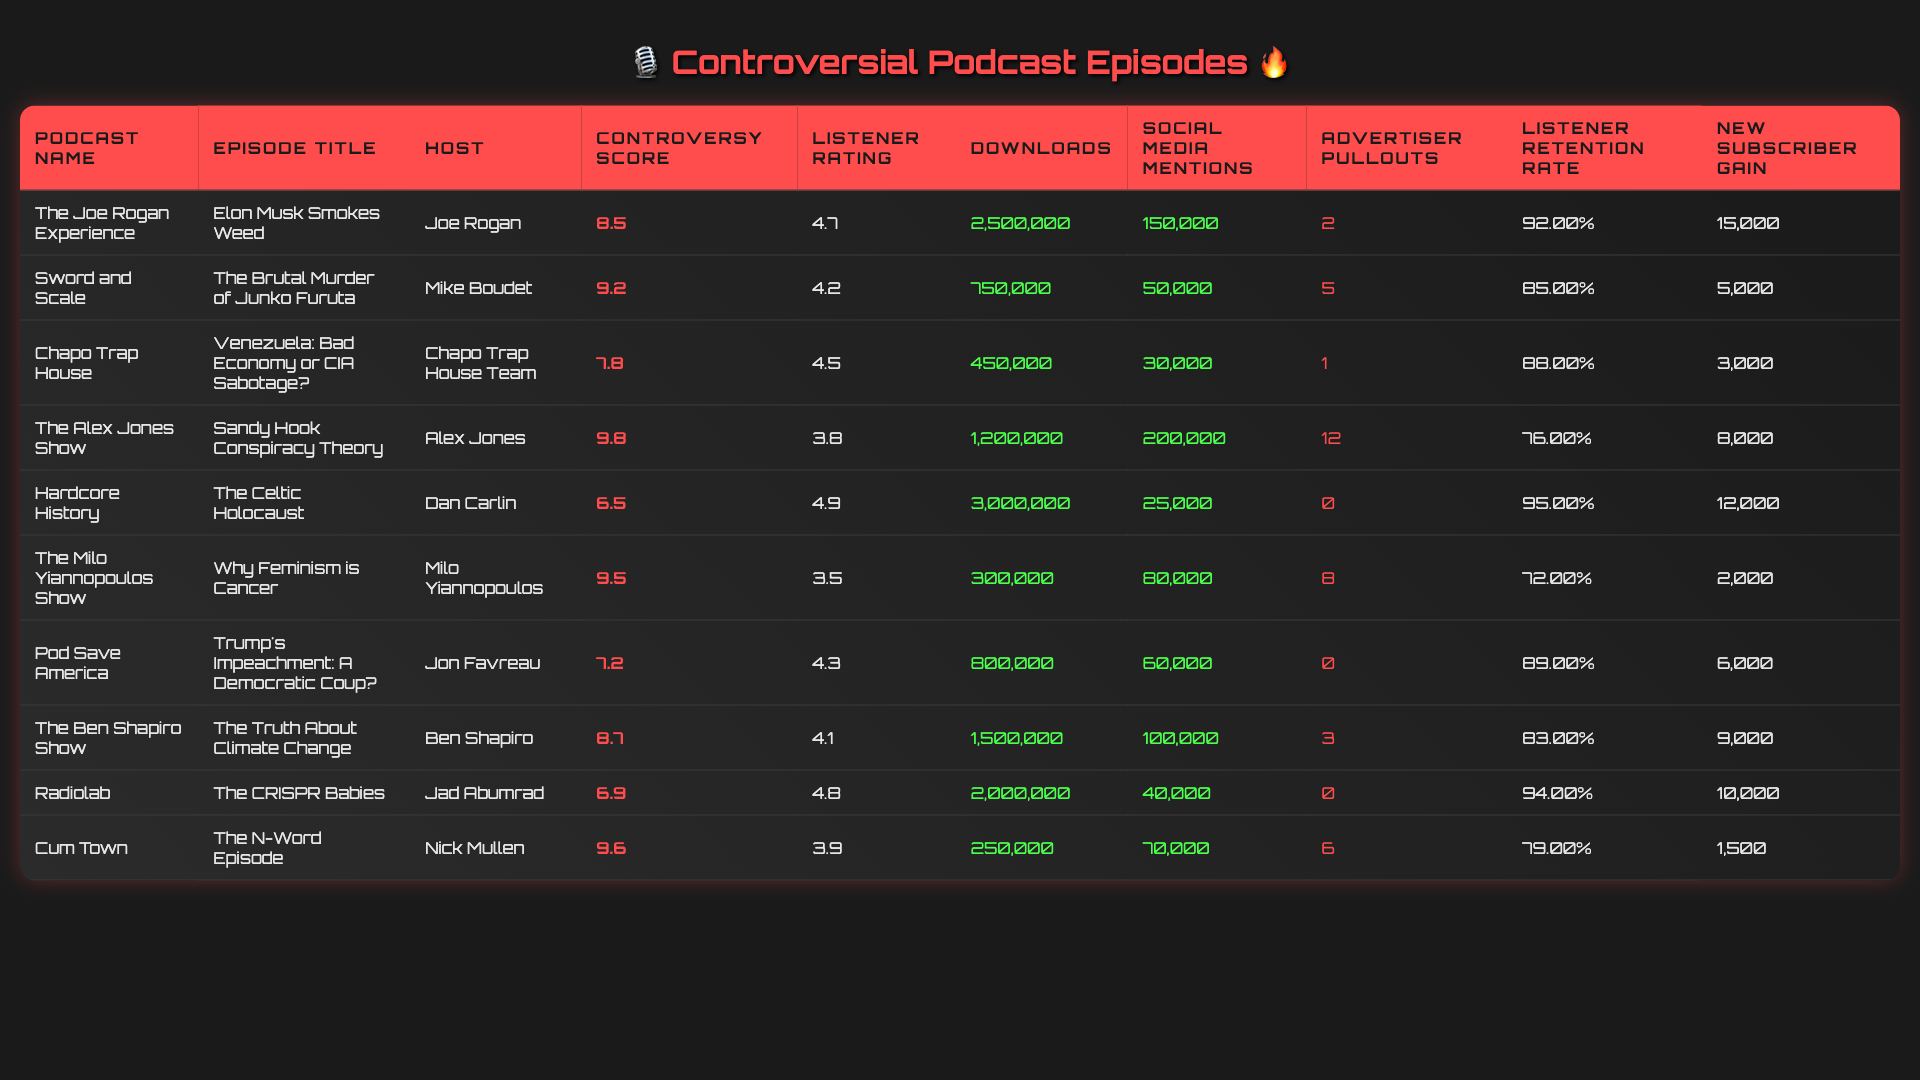What is the podcast with the highest controversy score? By scanning the controversy scores listed in the table, "The Alex Jones Show" has the highest score of 9.8.
Answer: The Alex Jones Show Which episode had the lowest listener rating? Looking at the listener ratings, "The Milo Yiannopoulos Show" has the lowest rating of 3.5.
Answer: The Milo Yiannopoulos Show How many downloads did "Cum Town" have? The table shows that "Cum Town" had 250,000 downloads.
Answer: 250,000 What is the average listener retention rate for the podcasts listed? The listener retention rates are 0.92, 0.85, 0.88, 0.76, 0.95, 0.72, 0.89, 0.83, 0.94, and 0.79. If we sum these values, we get 8.88, and dividing by 10 gives an average of 0.888 or 88.8%.
Answer: 88.8% Did any podcast have no advertiser pullouts? By reviewing the advertiser pullouts, "Hardcore History," "Pod Save America," and "The CRISPR Babies" had zero advertiser pullouts. Hence, the answer is yes.
Answer: Yes Which podcast had the highest downloads among those with a controversy score over 9? The podcasts with a score over 9 are "The Alex Jones Show," "Sword and Scale," and "The Milo Yiannopoulos Show." Among these, "The Alex Jones Show" has 1,200,000 downloads, which is the highest.
Answer: The Alex Jones Show What is the total number of social media mentions for "Elon Musk Smokes Weed" and "The N-Word Episode"? For "Elon Musk Smokes Weed," there are 150,000 mentions; for "The N-Word Episode," there are 70,000. Therefore, the total is 150,000 + 70,000 = 220,000 mentions.
Answer: 220,000 Which podcast had the highest new subscriber gain? According to the table, "The Joe Rogan Experience" had the highest new subscriber gain of 15,000.
Answer: The Joe Rogan Experience Is there a relationship between controversy score and listener retention rate? A higher controversy score does not necessarily correlate with a higher listener retention rate. For example, "The Alex Jones Show" (9.8) has a retention rate of 76%, while "Hardcore History" (6.5) has a higher retention rate of 95%. This indicates that high controversy could lead to lower retention in some cases.
Answer: No clear relationship What was the difference in downloads between "Sword and Scale" and "Cum Town"? "Sword and Scale" had 750,000 downloads, and "Cum Town" had 250,000 downloads. The difference is 750,000 - 250,000 = 500,000 downloads.
Answer: 500,000 